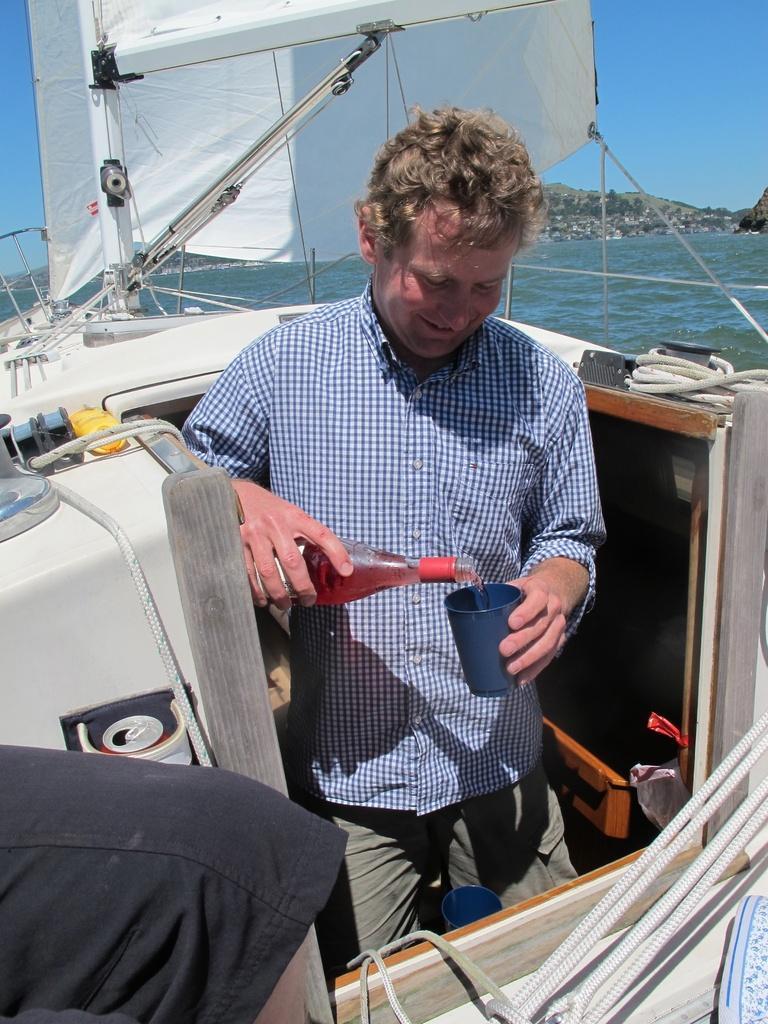Could you give a brief overview of what you see in this image? There is a man standing is holding a bottle and a cup. There are ropes. And it is a boat. Also there is a cloth. In the background there is water, hill and sky. 